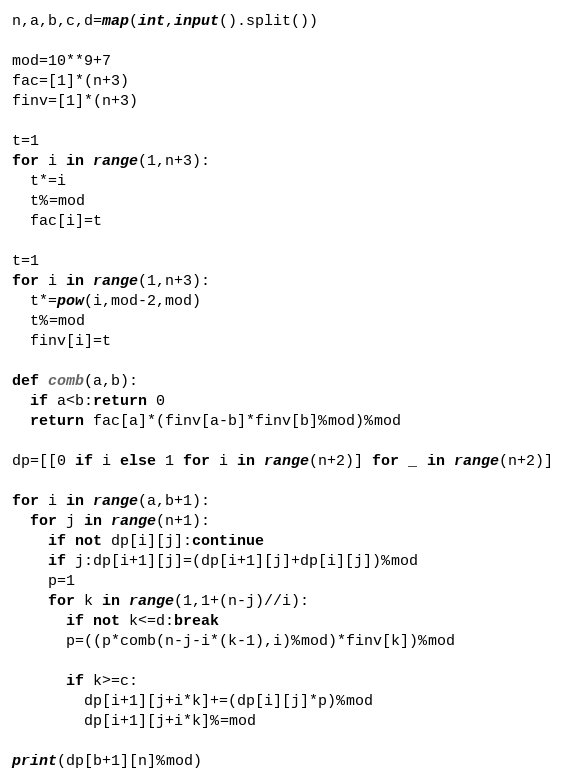<code> <loc_0><loc_0><loc_500><loc_500><_Python_>n,a,b,c,d=map(int,input().split())

mod=10**9+7
fac=[1]*(n+3)
finv=[1]*(n+3)

t=1
for i in range(1,n+3):
  t*=i
  t%=mod
  fac[i]=t

t=1
for i in range(1,n+3):
  t*=pow(i,mod-2,mod)
  t%=mod
  finv[i]=t

def comb(a,b):
  if a<b:return 0
  return fac[a]*(finv[a-b]*finv[b]%mod)%mod

dp=[[0 if i else 1 for i in range(n+2)] for _ in range(n+2)]

for i in range(a,b+1):
  for j in range(n+1):
    if not dp[i][j]:continue
    if j:dp[i+1][j]=(dp[i+1][j]+dp[i][j])%mod
    p=1
    for k in range(1,1+(n-j)//i):
      if not k<=d:break
      p=((p*comb(n-j-i*(k-1),i)%mod)*finv[k])%mod

      if k>=c:
        dp[i+1][j+i*k]+=(dp[i][j]*p)%mod
        dp[i+1][j+i*k]%=mod

print(dp[b+1][n]%mod)</code> 